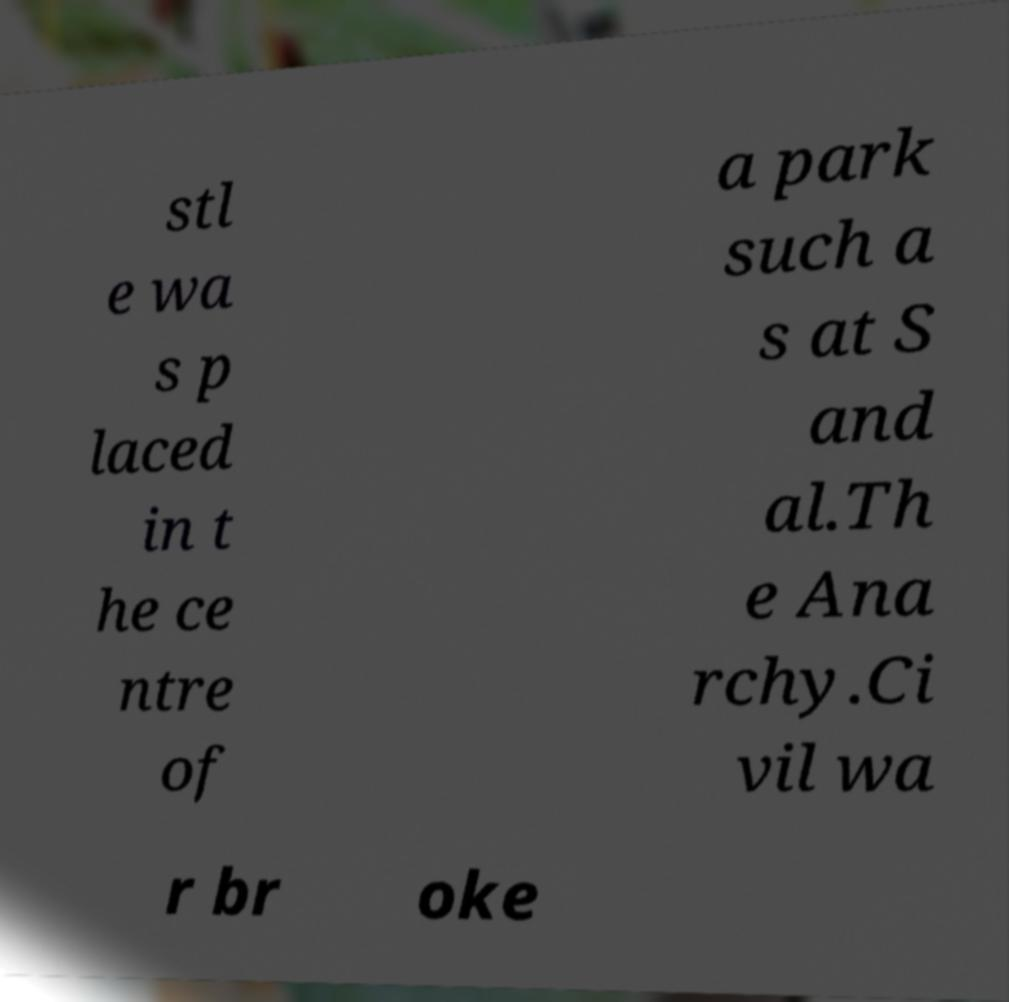Can you accurately transcribe the text from the provided image for me? stl e wa s p laced in t he ce ntre of a park such a s at S and al.Th e Ana rchy.Ci vil wa r br oke 